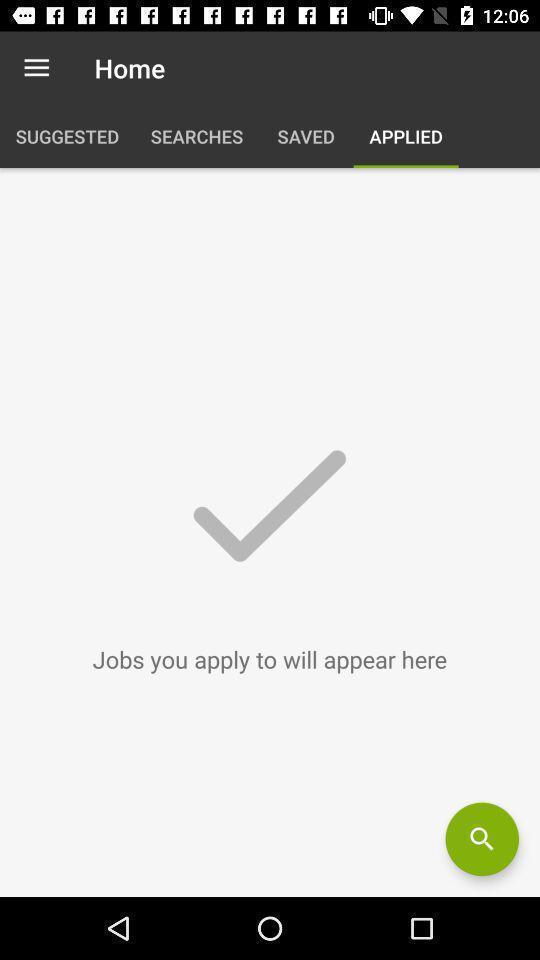Provide a detailed account of this screenshot. Page showing your applied job list. 